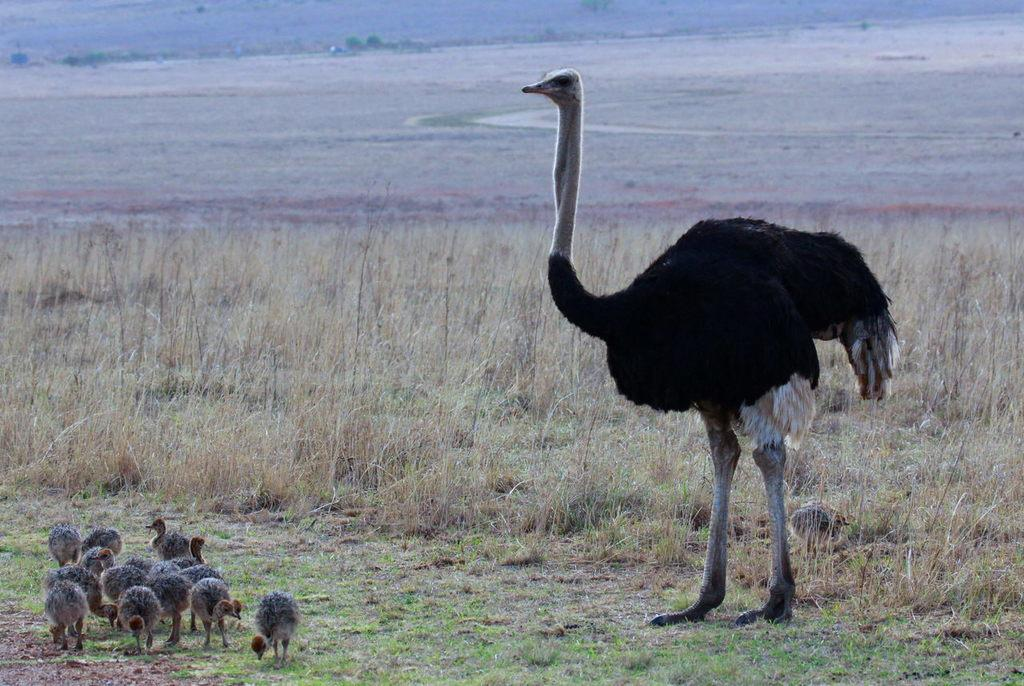What type of animal is on the right side of the image? There is an ostrich on the right side of the image. What can be seen on the left side of the image? There are ostrich babies on the left side of the image. What is the color of the grass visible in the image? The grass visible in the image is green. What type of mitten is being used to hold the loaf of bread in the image? There is no mitten or loaf of bread present in the image; it features an ostrich and ostrich babies in a grassy environment. 